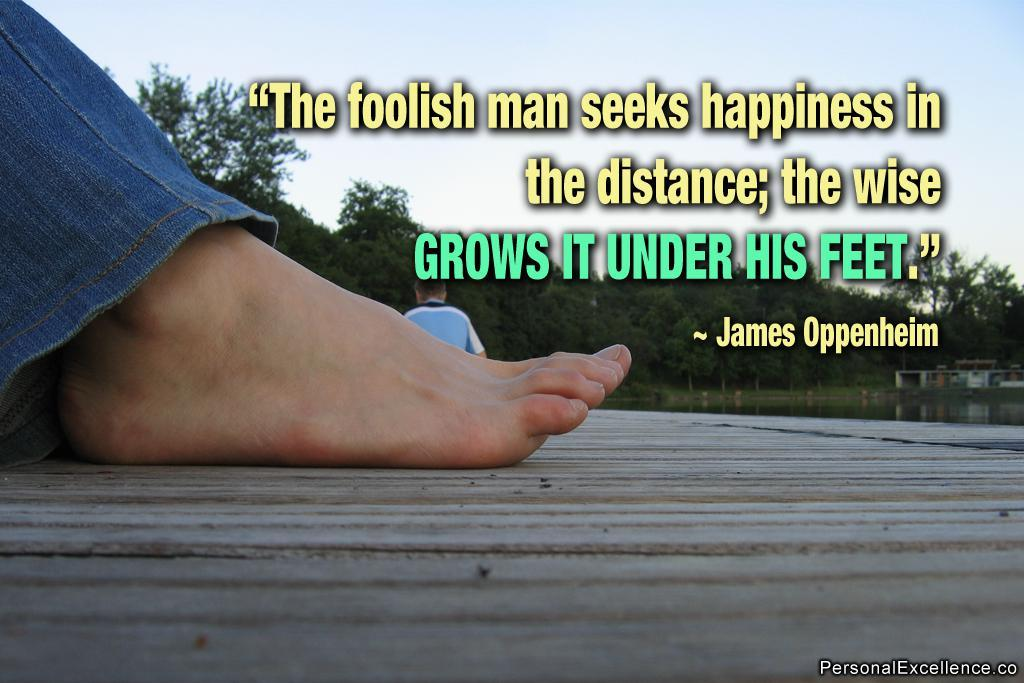What part of a person can be seen in the image? There is a leg of a person in the image. Where is the leg located in the image? The leg is on the floor. What is written above the leg in the image? There is a quote written above the leg. How was the image created or modified? The image is edited. How many windows are visible in the image? There are no windows visible in the image; it only features a leg, a quote, and the floor. 